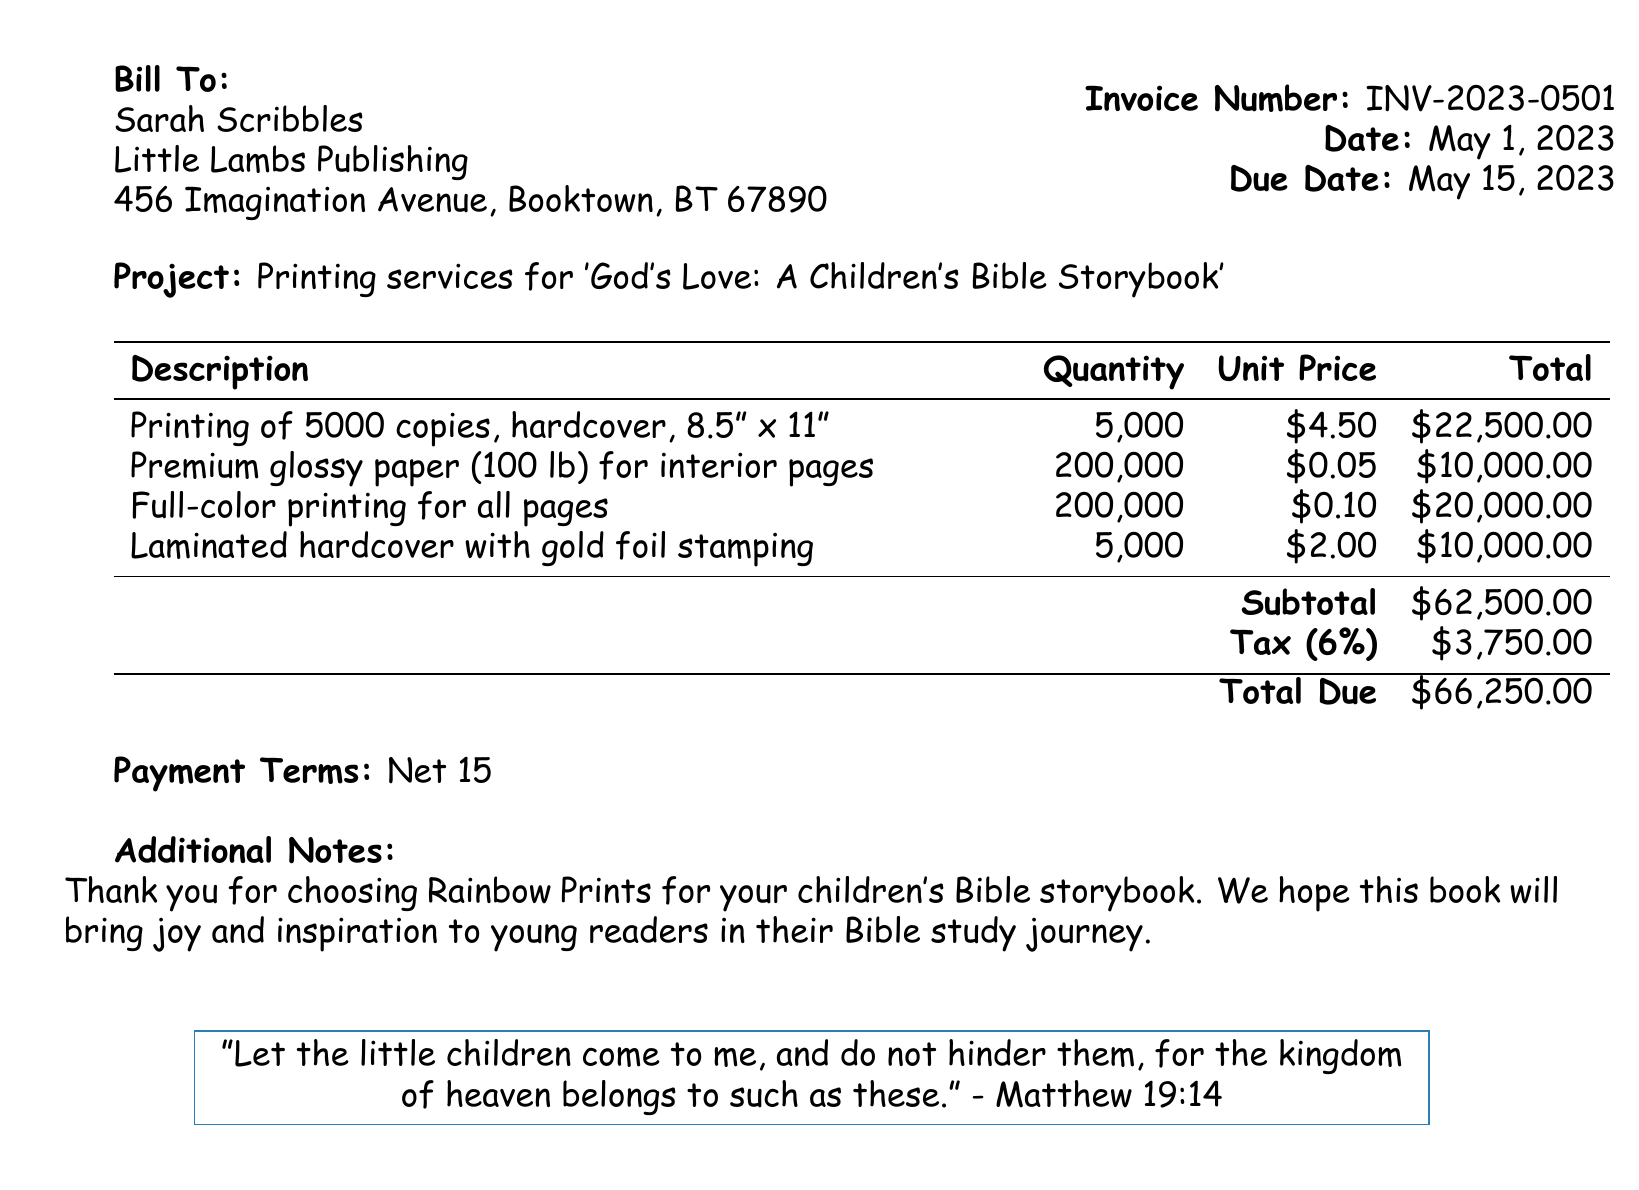What is the invoice number? The invoice number is specifically mentioned in the document under invoice details.
Answer: INV-2023-0501 Who is the bill to? The recipient of the bill is stated in the "Bill To" section of the document.
Answer: Sarah Scribbles What is the total due amount? The total due amount is highlighted in the totals section of the invoice.
Answer: $66,250.00 How many copies of the book are being printed? The quantity of copies printed is stated in the description of the printing services.
Answer: 5000 What is the unit price for premium glossy paper? The unit price for premium glossy paper is mentioned in the table of costs for printing services.
Answer: $0.05 What is the tax percentage applied in the invoice? The tax percentage is clearly stated in the tax line of the totals section.
Answer: 6% What size are the hardcover copies? The dimensions of the hardcover copies are provided in the description of services.
Answer: 8.5" x 11" What does the additional note thank the recipient for? The additional note expresses gratitude for a specific service provided, as detailed in the document.
Answer: Choosing Rainbow Prints What is the payment term for this invoice? The payment terms are clearly indicated in the invoice's terms and conditions section.
Answer: Net 15 